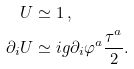Convert formula to latex. <formula><loc_0><loc_0><loc_500><loc_500>U & \simeq 1 \, , \\ \partial _ { i } U & \simeq i g \partial _ { i } \varphi ^ { a } \frac { \tau ^ { a } } { 2 } .</formula> 